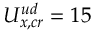<formula> <loc_0><loc_0><loc_500><loc_500>U _ { x , c r } ^ { u d } = 1 5</formula> 